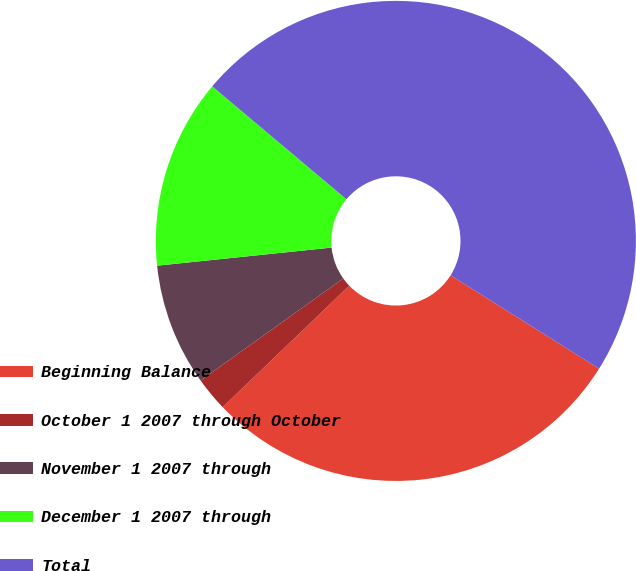Convert chart. <chart><loc_0><loc_0><loc_500><loc_500><pie_chart><fcel>Beginning Balance<fcel>October 1 2007 through October<fcel>November 1 2007 through<fcel>December 1 2007 through<fcel>Total<nl><fcel>28.89%<fcel>2.3%<fcel>8.23%<fcel>12.78%<fcel>47.8%<nl></chart> 